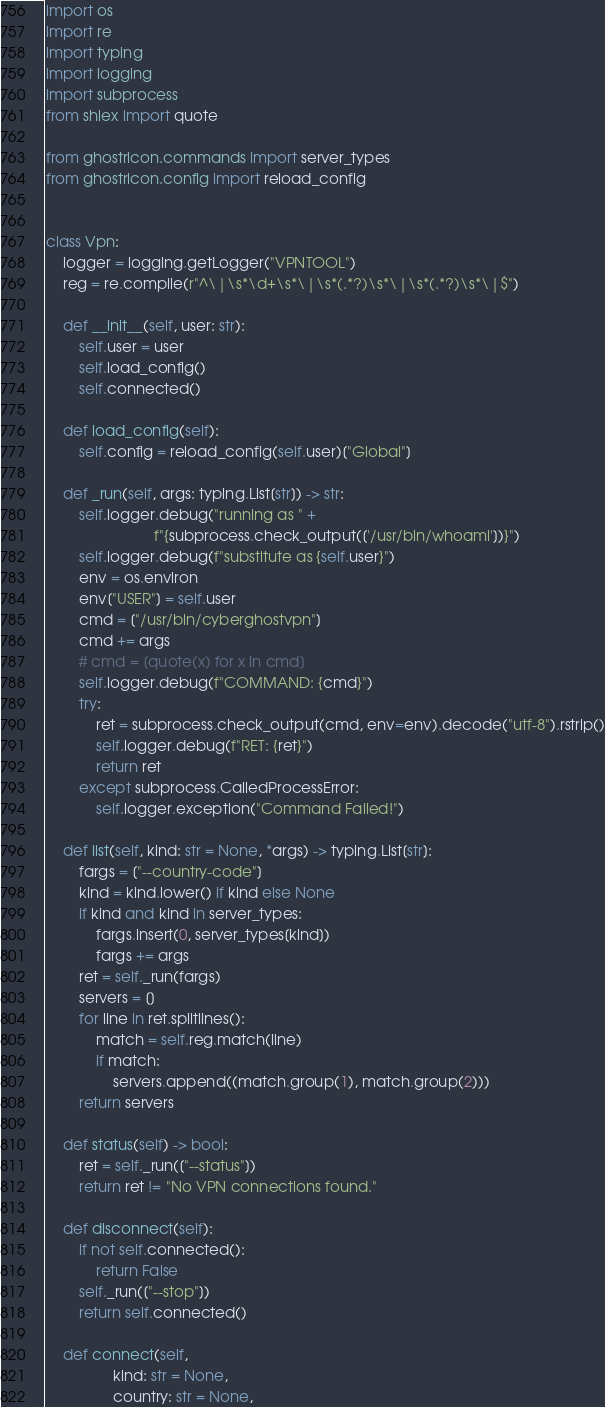<code> <loc_0><loc_0><loc_500><loc_500><_Python_>import os
import re
import typing
import logging
import subprocess
from shlex import quote

from ghostricon.commands import server_types
from ghostricon.config import reload_config


class Vpn:
    logger = logging.getLogger("VPNTOOL")
    reg = re.compile(r"^\|\s*\d+\s*\|\s*(.*?)\s*\|\s*(.*?)\s*\|$")

    def __init__(self, user: str):
        self.user = user
        self.load_config()
        self.connected()

    def load_config(self):
        self.config = reload_config(self.user)["Global"]

    def _run(self, args: typing.List[str]) -> str:
        self.logger.debug("running as " +
                          f"{subprocess.check_output(['/usr/bin/whoami'])}")
        self.logger.debug(f"substitute as {self.user}")
        env = os.environ
        env["USER"] = self.user
        cmd = ["/usr/bin/cyberghostvpn"]
        cmd += args
        # cmd = [quote(x) for x in cmd]
        self.logger.debug(f"COMMAND: {cmd}")
        try:
            ret = subprocess.check_output(cmd, env=env).decode("utf-8").rstrip()
            self.logger.debug(f"RET: {ret}")
            return ret
        except subprocess.CalledProcessError:
            self.logger.exception("Command Failed!")

    def list(self, kind: str = None, *args) -> typing.List[str]:
        fargs = ["--country-code"]
        kind = kind.lower() if kind else None
        if kind and kind in server_types:
            fargs.insert(0, server_types[kind])
            fargs += args
        ret = self._run(fargs)
        servers = []
        for line in ret.splitlines():
            match = self.reg.match(line)
            if match:
                servers.append((match.group(1), match.group(2)))
        return servers

    def status(self) -> bool:
        ret = self._run(["--status"])
        return ret != "No VPN connections found."

    def disconnect(self):
        if not self.connected():
            return False
        self._run(["--stop"])
        return self.connected()

    def connect(self,
                kind: str = None,
                country: str = None,</code> 